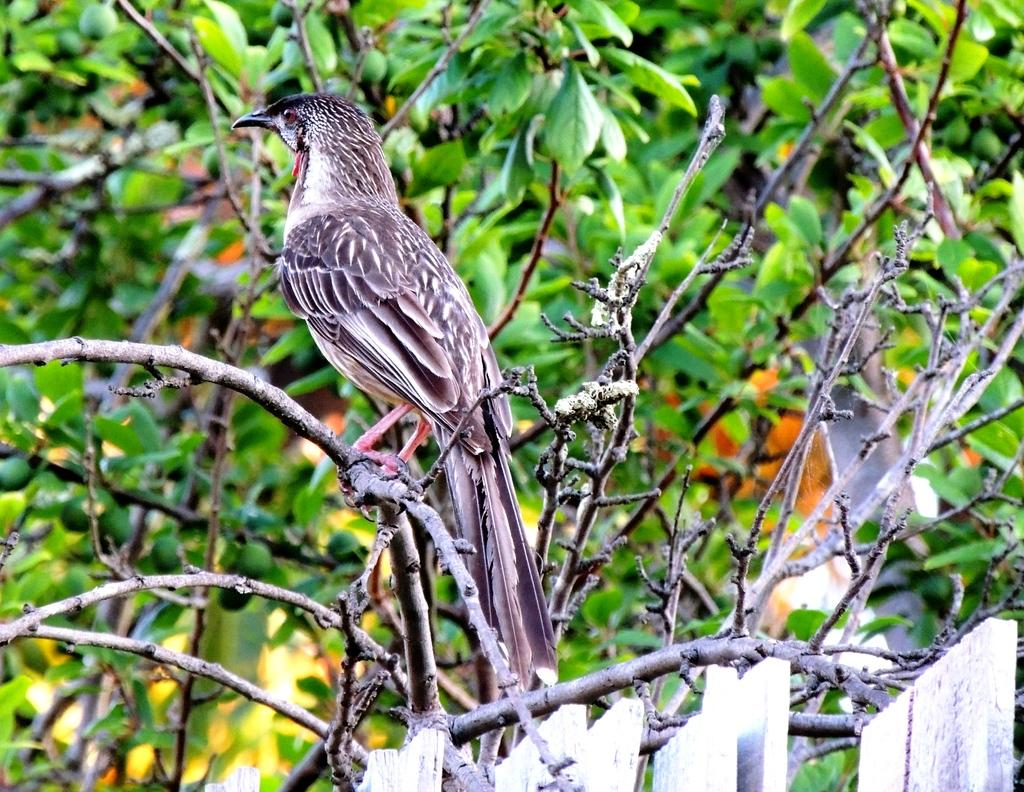What type of animal can be seen in the image? There is a bird in the image. Where is the bird located? The bird is on a branch. What can be seen in the background of the image? There are trees in the background of the image. What type of shoe is the bird wearing in the image? There is no shoe present in the image, as birds do not wear shoes. 